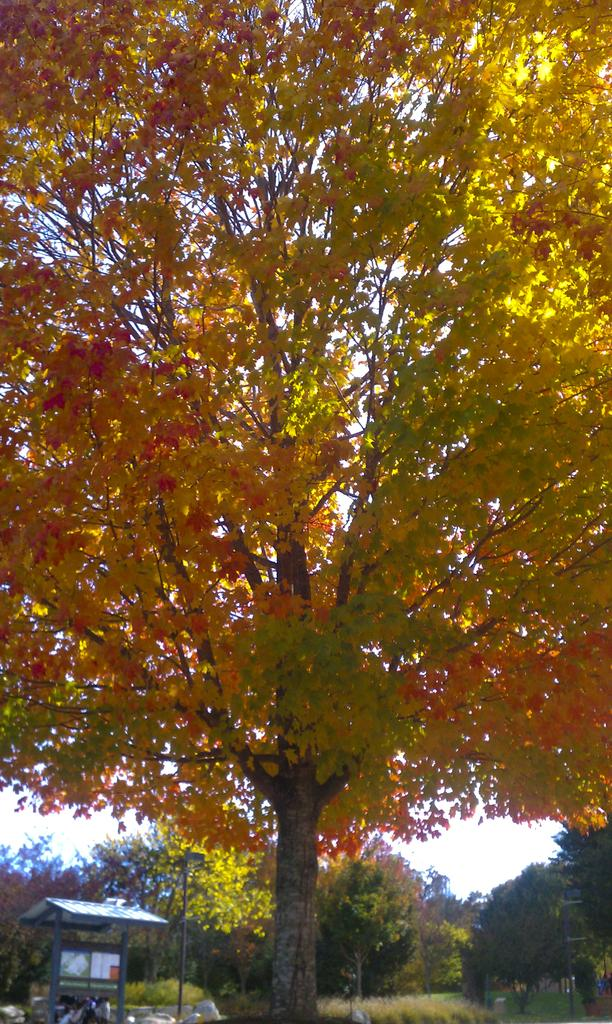What is the main subject in the middle of the image? There is a tree in the middle of the image. What can be seen behind the tree? There are trees behind the tree. What structures are visible in the background? There is a shed and poles in the background. What type of vegetation is present in the background? There are plants in the background. What else can be seen in the background? There are vehicles in the background. What is visible in the sky? There are clouds in the sky, and the sky is visible in the background. What type of fan is hanging from the tree in the image? There is no fan present in the image; it features a tree, other trees, a shed, poles, plants, vehicles, clouds, and the sky. 